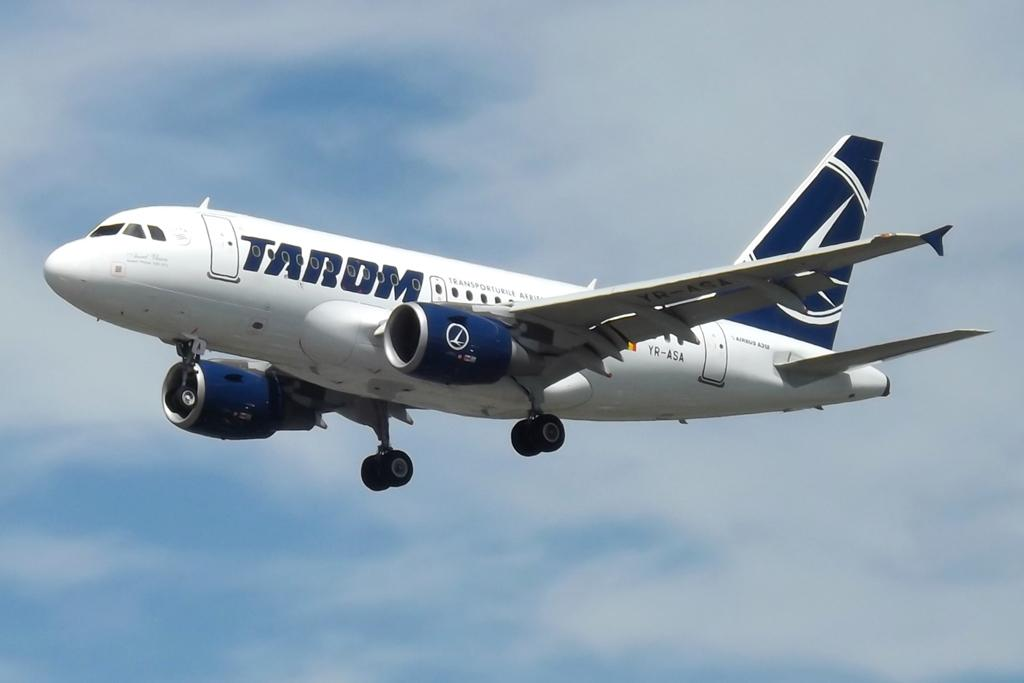<image>
Share a concise interpretation of the image provided. A TARDM aircraft is flying with its landing gear down. 